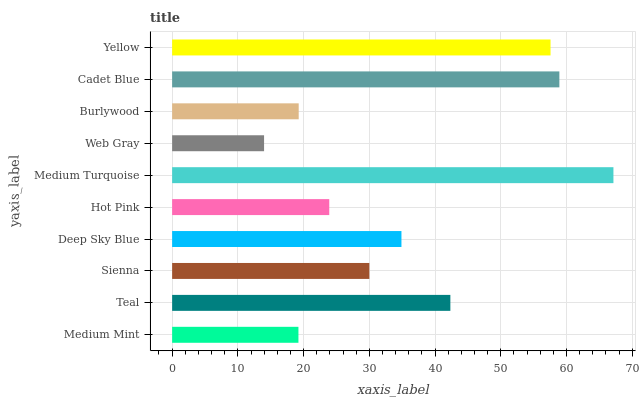Is Web Gray the minimum?
Answer yes or no. Yes. Is Medium Turquoise the maximum?
Answer yes or no. Yes. Is Teal the minimum?
Answer yes or no. No. Is Teal the maximum?
Answer yes or no. No. Is Teal greater than Medium Mint?
Answer yes or no. Yes. Is Medium Mint less than Teal?
Answer yes or no. Yes. Is Medium Mint greater than Teal?
Answer yes or no. No. Is Teal less than Medium Mint?
Answer yes or no. No. Is Deep Sky Blue the high median?
Answer yes or no. Yes. Is Sienna the low median?
Answer yes or no. Yes. Is Cadet Blue the high median?
Answer yes or no. No. Is Medium Turquoise the low median?
Answer yes or no. No. 